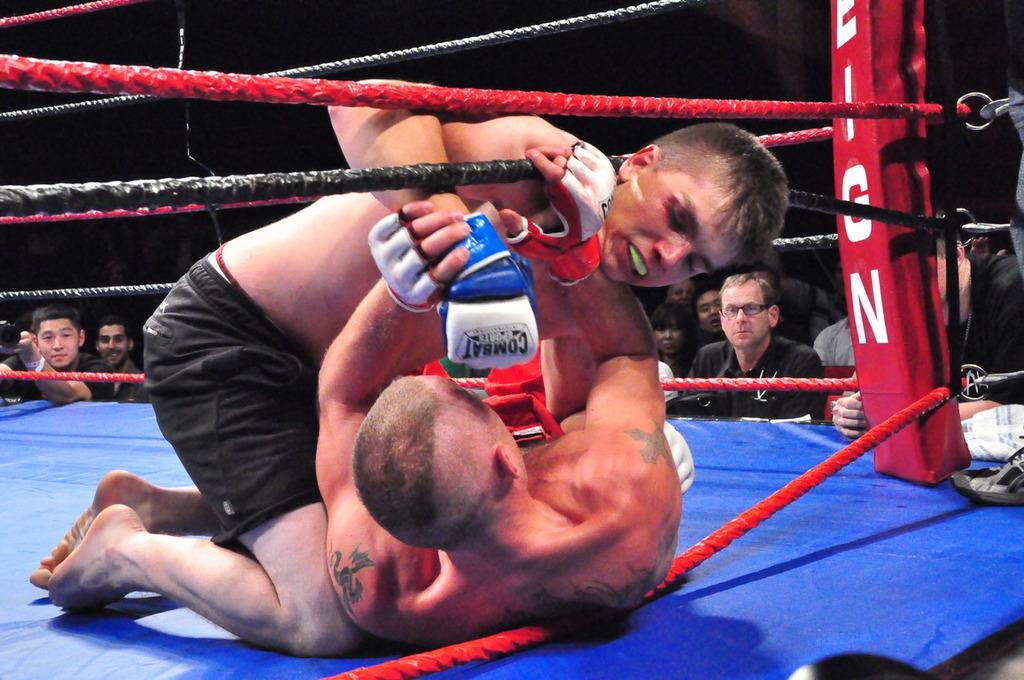How many people are involved in the altercation in the image? There are two men in the image who are fighting. What is the color of the surface they are fighting on? The surface they are fighting on is blue. What objects can be seen near the men while they are fighting? There are ropes visible in the image. What is happening in the background of the image? There is a group of people in the background watching the fight. How would you describe the lighting in the image? The overall view of the image is dark. Can you see a frog hopping on the blue surface in the image? No, there is no frog present in the image. What type of shoe is being used by one of the fighters in the image? There is no shoe visible in the image; the focus is on the men fighting and the ropes. 